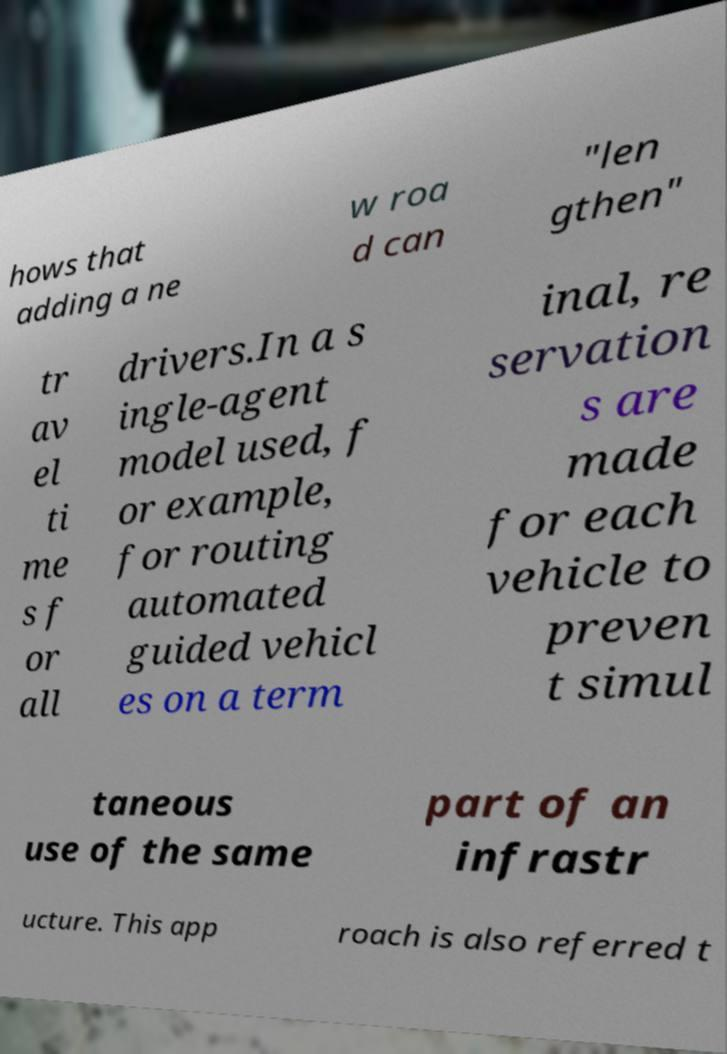For documentation purposes, I need the text within this image transcribed. Could you provide that? hows that adding a ne w roa d can "len gthen" tr av el ti me s f or all drivers.In a s ingle-agent model used, f or example, for routing automated guided vehicl es on a term inal, re servation s are made for each vehicle to preven t simul taneous use of the same part of an infrastr ucture. This app roach is also referred t 